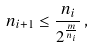<formula> <loc_0><loc_0><loc_500><loc_500>n _ { i + 1 } \leq \frac { n _ { i } } { 2 ^ { \frac { m } { n _ { i } } } } \, ,</formula> 